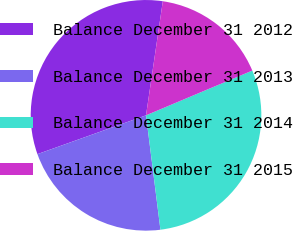<chart> <loc_0><loc_0><loc_500><loc_500><pie_chart><fcel>Balance December 31 2012<fcel>Balance December 31 2013<fcel>Balance December 31 2014<fcel>Balance December 31 2015<nl><fcel>32.79%<fcel>21.53%<fcel>29.35%<fcel>16.33%<nl></chart> 